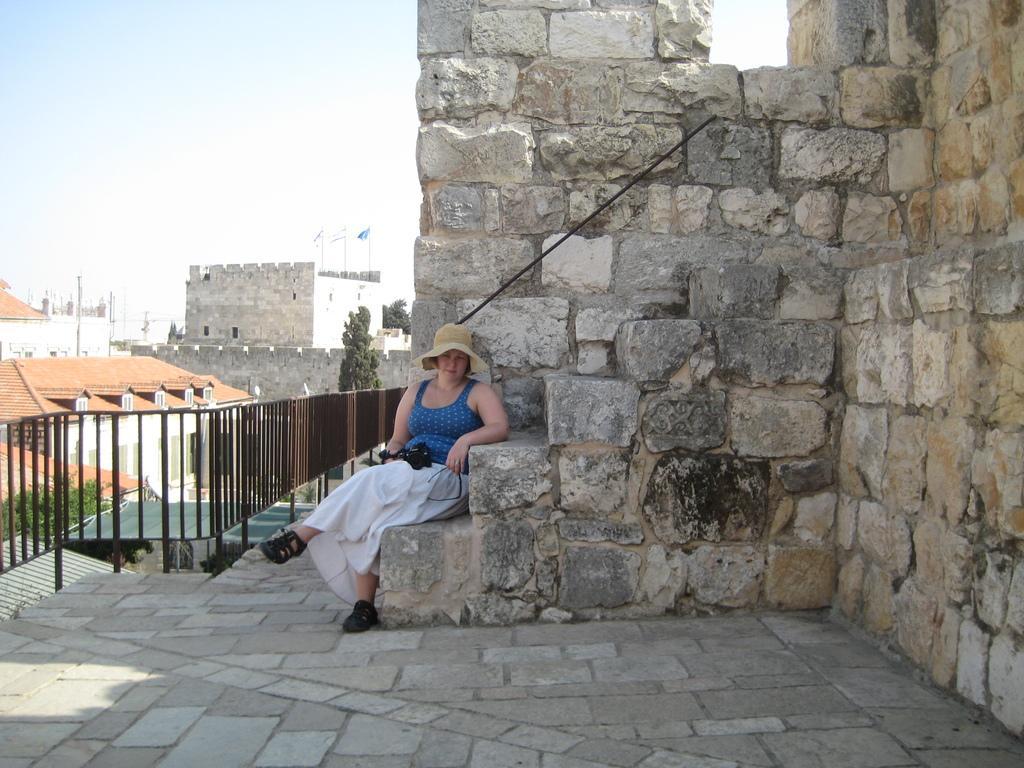How would you summarize this image in a sentence or two? In this image there is a woman holding a camera is sitting on the rock stairs, behind the woman there are rocks, metal fence, trees and buildings, on the buildings there are flags. 